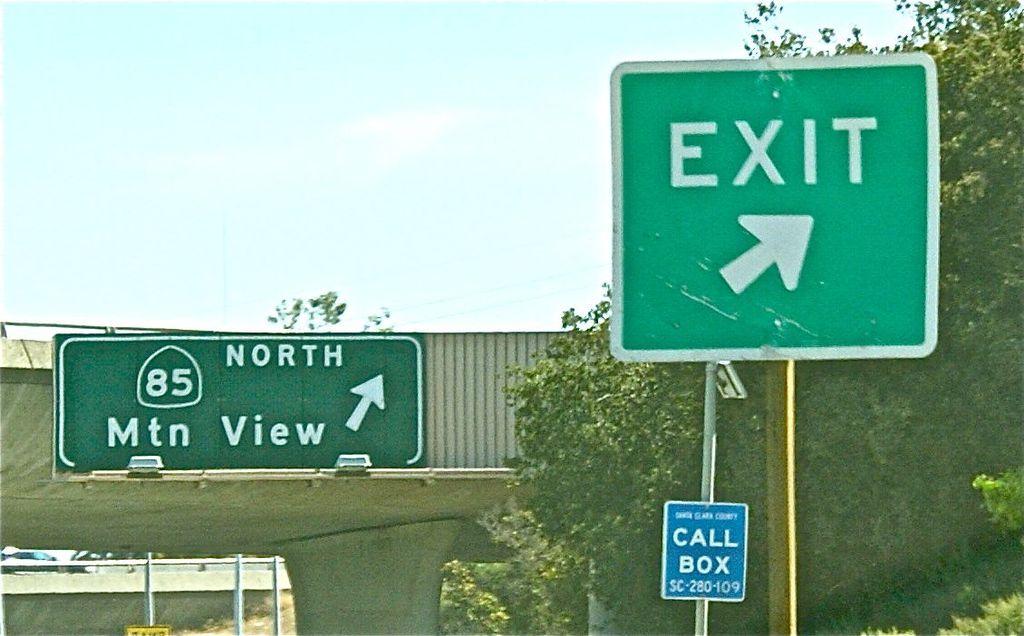What highway is ahead?
Keep it short and to the point. 85. 